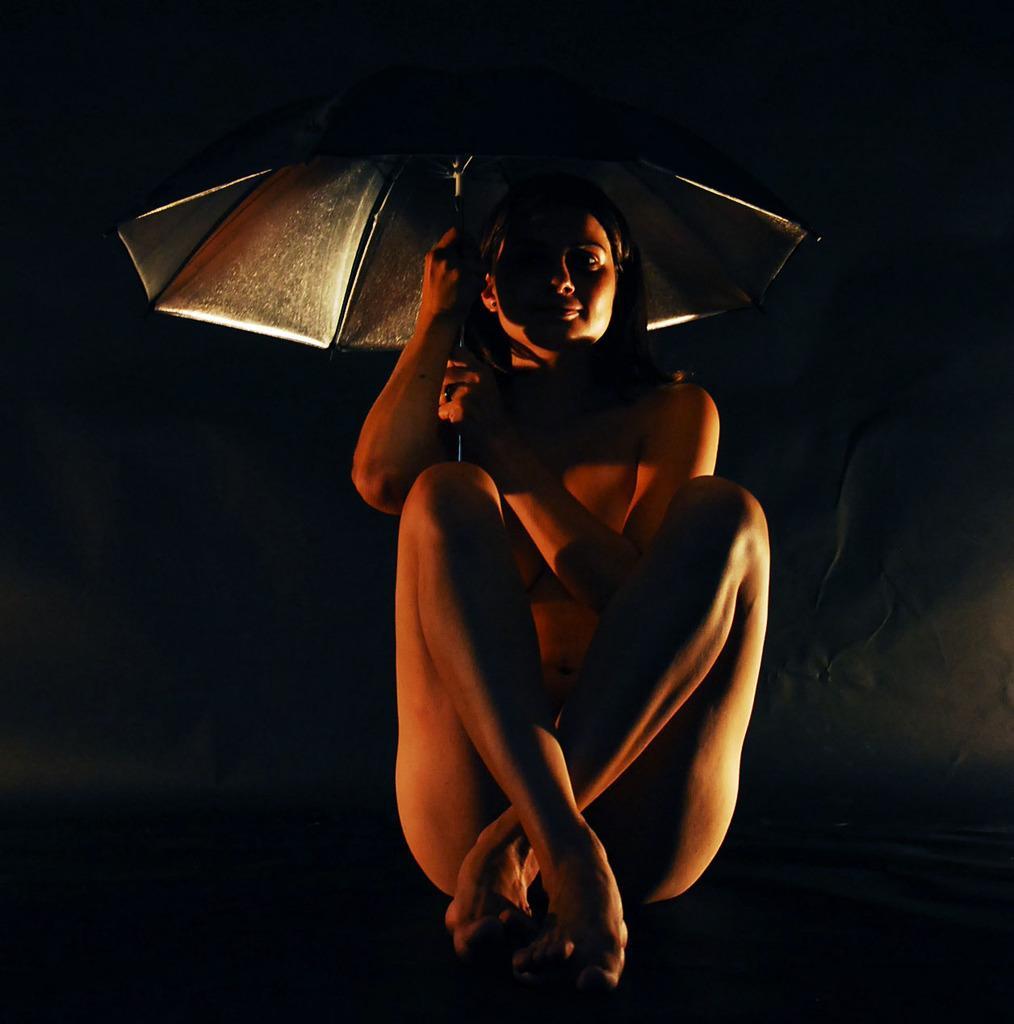Could you give a brief overview of what you see in this image? In this image we can see a woman sitting and holding an umbrella. 